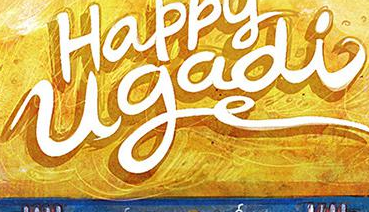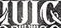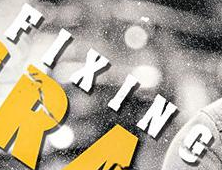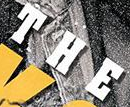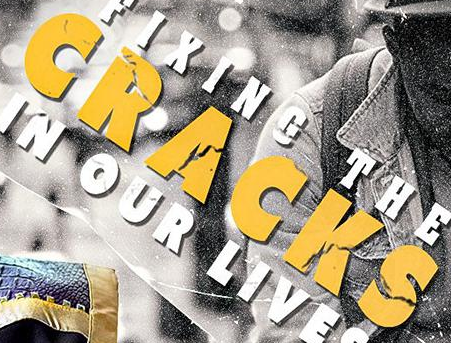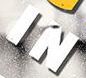Transcribe the words shown in these images in order, separated by a semicolon. ugadi; IUIC; FIXING; THE; CRACKS; IN 